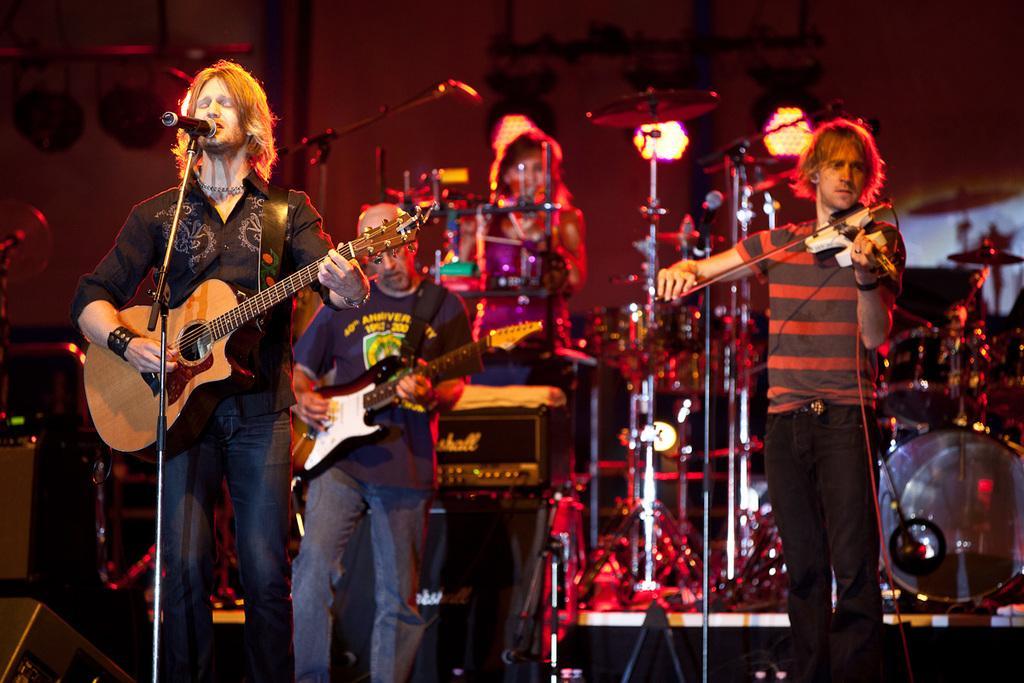Can you describe this image briefly? The person wearing black shirt is playing guitar and singing in front of a mic, There is another person standing beside him who is playing violin, The person wearing blue shirt is playing guitar, In background there is a lady sitting in front of some musical instruments. 